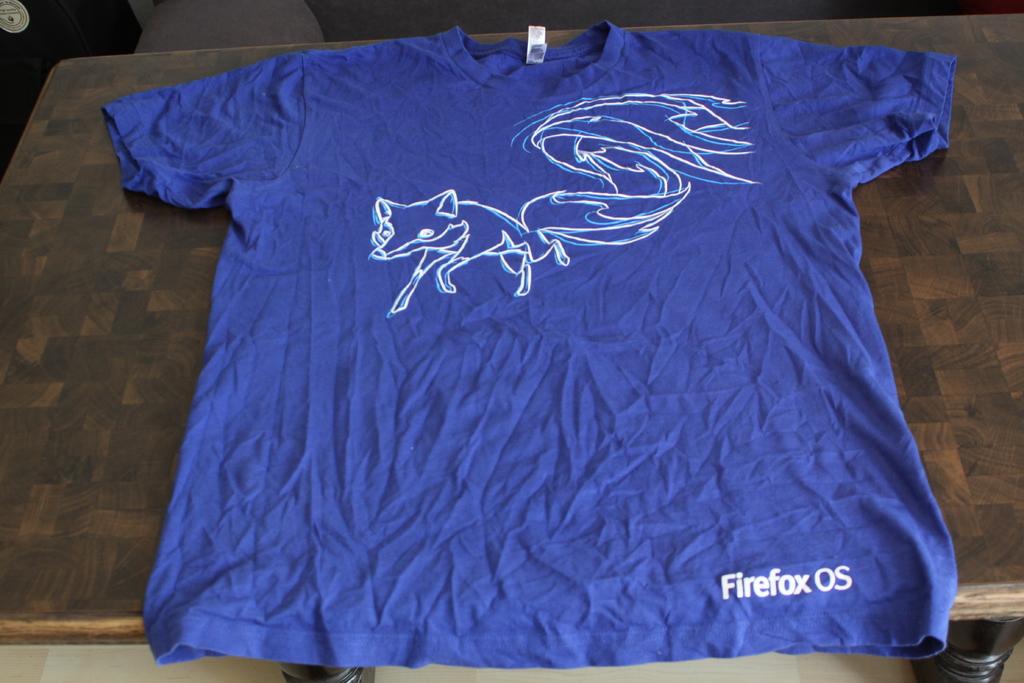What software is this shirt from?
Your response must be concise. Firefox os. What is written on the bottom right of the shirt?
Ensure brevity in your answer.  Firefox os. 